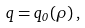Convert formula to latex. <formula><loc_0><loc_0><loc_500><loc_500>q = q _ { 0 } ( \rho ) \, ,</formula> 